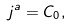<formula> <loc_0><loc_0><loc_500><loc_500>j ^ { a } = C _ { 0 } ,</formula> 